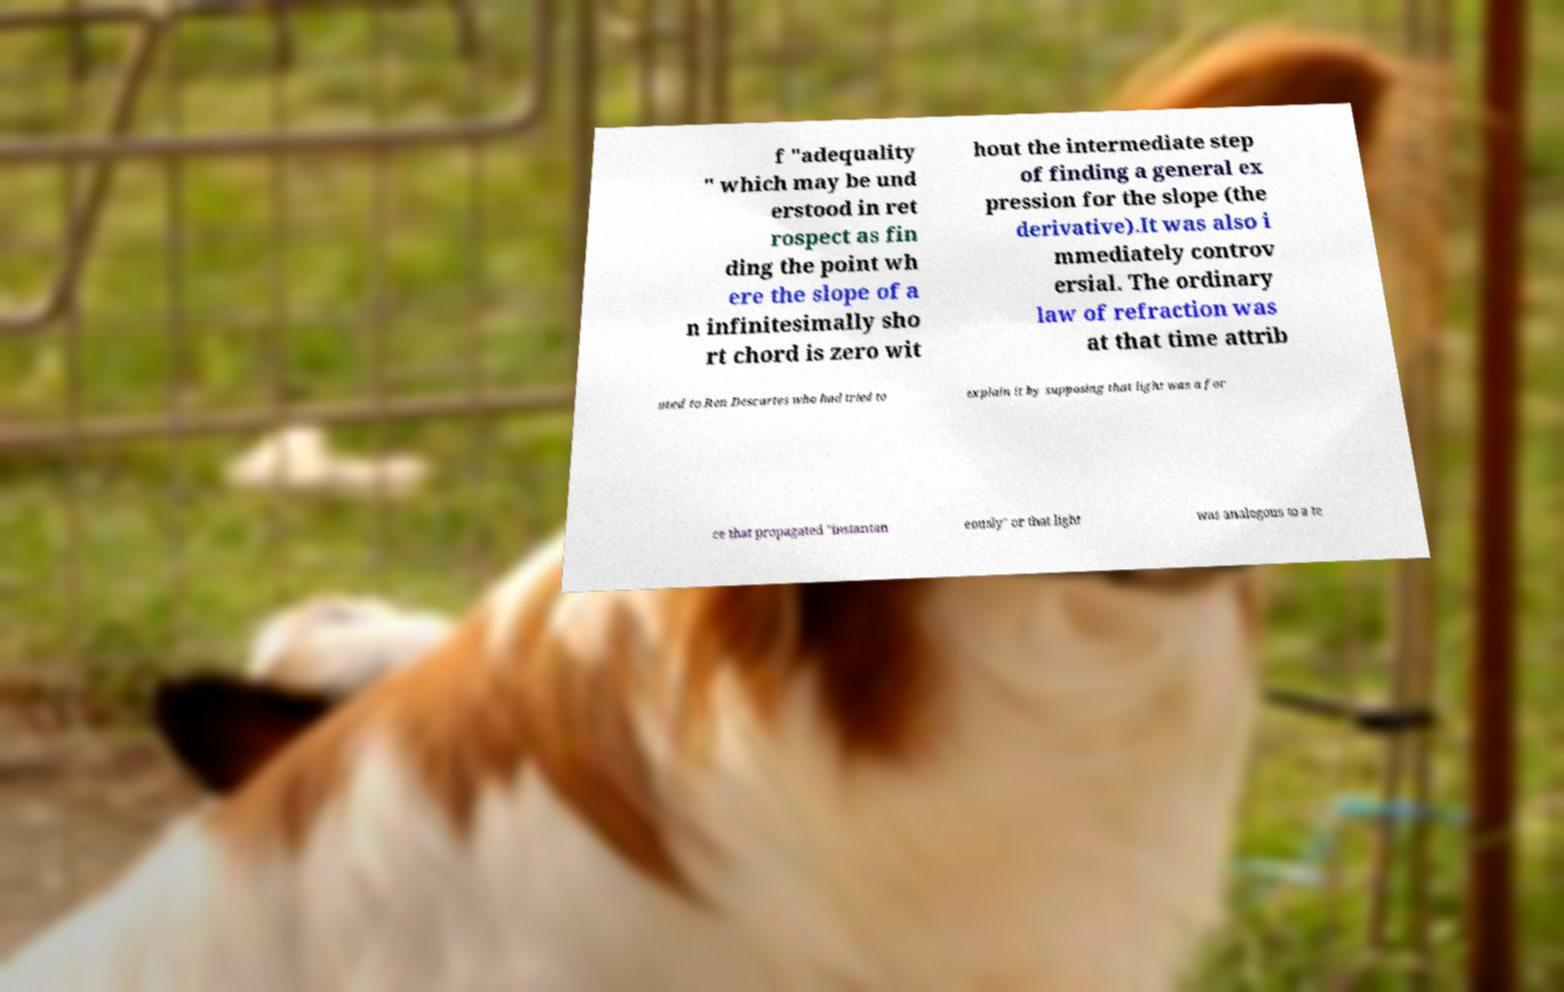Please read and relay the text visible in this image. What does it say? f "adequality " which may be und erstood in ret rospect as fin ding the point wh ere the slope of a n infinitesimally sho rt chord is zero wit hout the intermediate step of finding a general ex pression for the slope (the derivative).It was also i mmediately controv ersial. The ordinary law of refraction was at that time attrib uted to Ren Descartes who had tried to explain it by supposing that light was a for ce that propagated "instantan eously" or that light was analogous to a te 